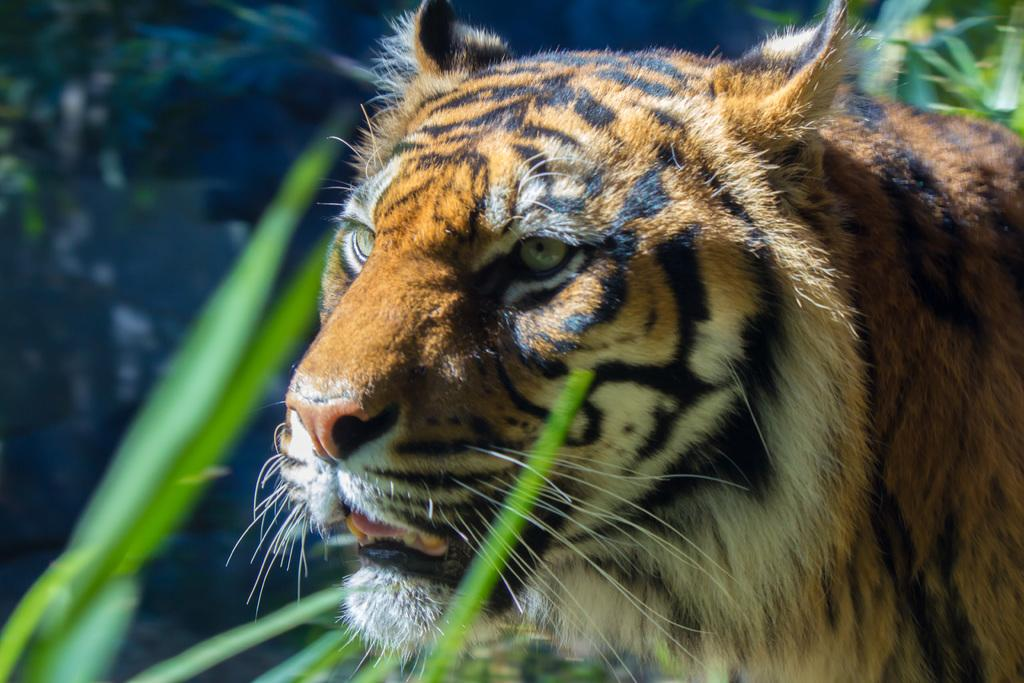What is the main subject in the center of the image? There is a tiger in the center of the image. What can be seen in the background of the image? There are plants in the background of the image. What type of cherry is the tiger holding in its mouth in the image? There is no cherry present in the image; the tiger is not holding anything in its mouth. Can you see a church in the background of the image? No, there is no church visible in the image; the background features plants. 